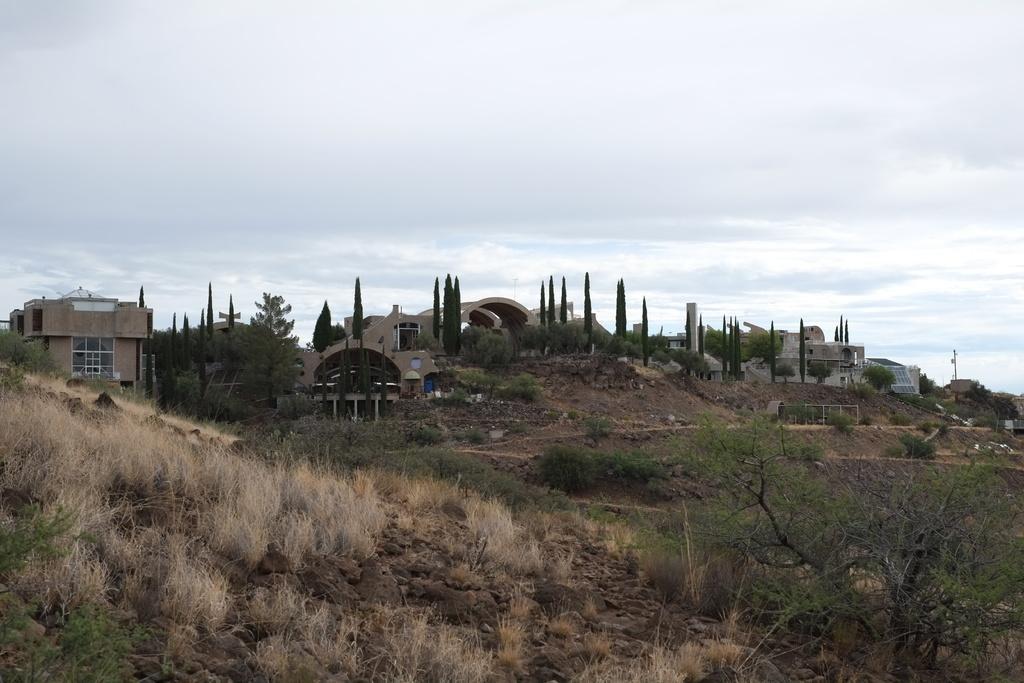Can you describe this image briefly? This picture might be taken from outside of the city. In this image, on the right side, we can see some trees. On the left side, we can see some rocks on grass. In the background, there are some trees, buildings, pole. On top there is a sky which is cloud, at the bottom there is a land with some stones. 